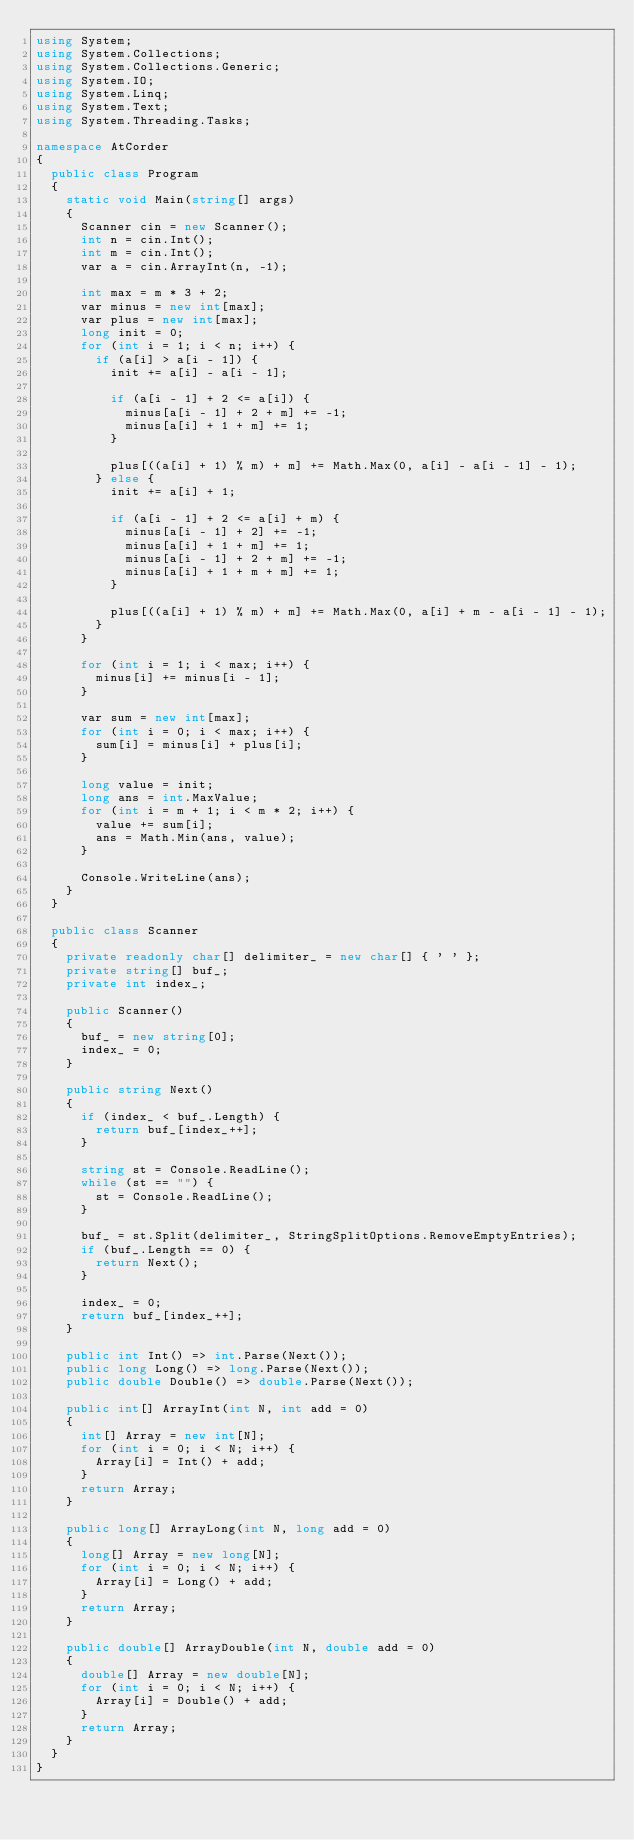<code> <loc_0><loc_0><loc_500><loc_500><_C#_>using System;
using System.Collections;
using System.Collections.Generic;
using System.IO;
using System.Linq;
using System.Text;
using System.Threading.Tasks;

namespace AtCorder
{
	public class Program
	{
		static void Main(string[] args)
		{
			Scanner cin = new Scanner();
			int n = cin.Int();
			int m = cin.Int();
			var a = cin.ArrayInt(n, -1);

			int max = m * 3 + 2;
			var minus = new int[max];
			var plus = new int[max];
			long init = 0;
			for (int i = 1; i < n; i++) {
				if (a[i] > a[i - 1]) {
					init += a[i] - a[i - 1];

					if (a[i - 1] + 2 <= a[i]) {
						minus[a[i - 1] + 2 + m] += -1;
						minus[a[i] + 1 + m] += 1;
					}

					plus[((a[i] + 1) % m) + m] += Math.Max(0, a[i] - a[i - 1] - 1);
				} else {
					init += a[i] + 1;

					if (a[i - 1] + 2 <= a[i] + m) {
						minus[a[i - 1] + 2] += -1;
						minus[a[i] + 1 + m] += 1;
						minus[a[i - 1] + 2 + m] += -1;
						minus[a[i] + 1 + m + m] += 1;
					}

					plus[((a[i] + 1) % m) + m] += Math.Max(0, a[i] + m - a[i - 1] - 1);
				}
			}

			for (int i = 1; i < max; i++) {
				minus[i] += minus[i - 1];
			}

			var sum = new int[max];
			for (int i = 0; i < max; i++) {
				sum[i] = minus[i] + plus[i];
			}

			long value = init;
			long ans = int.MaxValue;
			for (int i = m + 1; i < m * 2; i++) {
				value += sum[i];
				ans = Math.Min(ans, value);
			}

			Console.WriteLine(ans);
		}
	}

	public class Scanner
	{
		private readonly char[] delimiter_ = new char[] { ' ' };
		private string[] buf_;
		private int index_;

		public Scanner()
		{
			buf_ = new string[0];
			index_ = 0;
		}

		public string Next()
		{
			if (index_ < buf_.Length) {
				return buf_[index_++];
			}

			string st = Console.ReadLine();
			while (st == "") {
				st = Console.ReadLine();
			}

			buf_ = st.Split(delimiter_, StringSplitOptions.RemoveEmptyEntries);
			if (buf_.Length == 0) {
				return Next();
			}

			index_ = 0;
			return buf_[index_++];
		}

		public int Int() => int.Parse(Next());
		public long Long() => long.Parse(Next());
		public double Double() => double.Parse(Next());

		public int[] ArrayInt(int N, int add = 0)
		{
			int[] Array = new int[N];
			for (int i = 0; i < N; i++) {
				Array[i] = Int() + add;
			}
			return Array;
		}

		public long[] ArrayLong(int N, long add = 0)
		{
			long[] Array = new long[N];
			for (int i = 0; i < N; i++) {
				Array[i] = Long() + add;
			}
			return Array;
		}

		public double[] ArrayDouble(int N, double add = 0)
		{
			double[] Array = new double[N];
			for (int i = 0; i < N; i++) {
				Array[i] = Double() + add;
			}
			return Array;
		}
	}
}</code> 